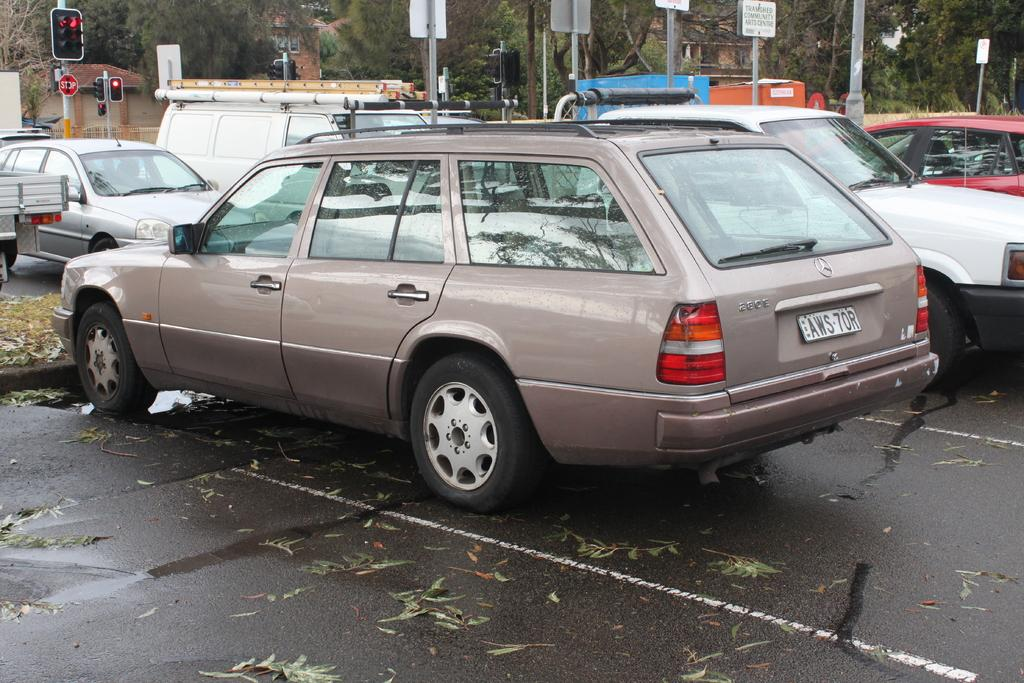What can be seen in the image that is used for transportation? There are parked cars in the image. What type of information might be conveyed by the sign boards in the image? The sign boards in the image might convey information about directions, rules, or advertisements. What is located on the left side of the image? There is a signal light on the left side of the image. What type of natural elements can be seen in the image? There are trees in the image. Where is the bucket used for watering the trees in the image? There is no bucket present in the image. What type of blade is being used to cut the signal light in the image? There is no blade or cutting activity present in the image; the signal light is stationary. 